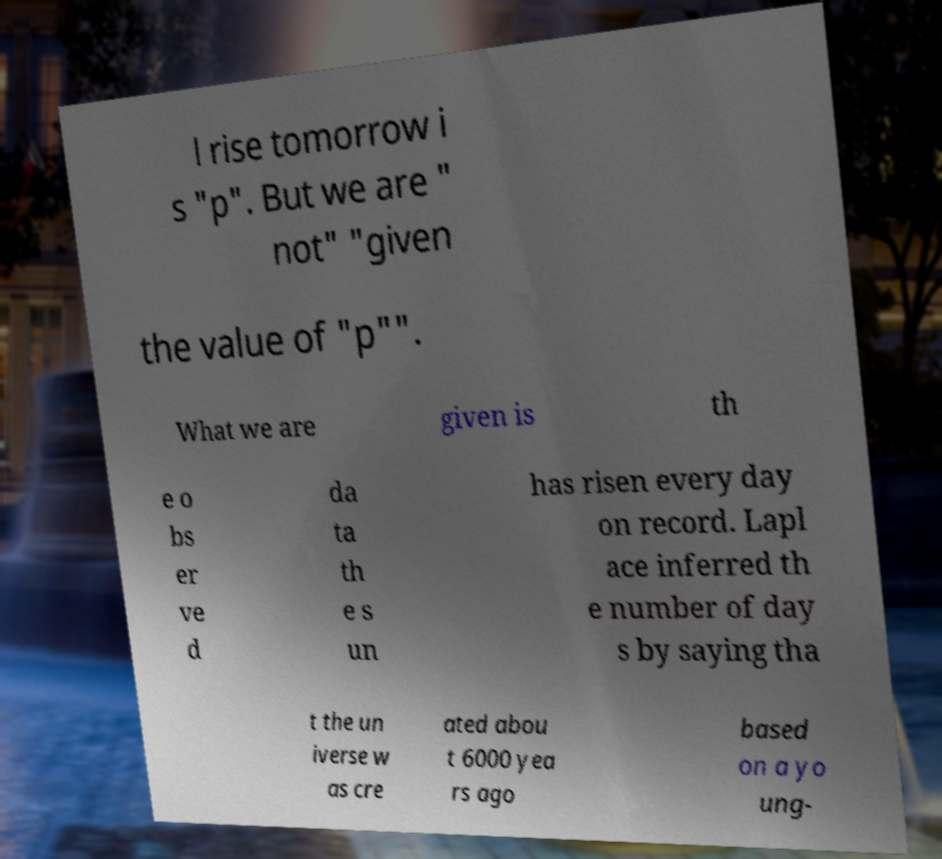There's text embedded in this image that I need extracted. Can you transcribe it verbatim? l rise tomorrow i s "p". But we are " not" "given the value of "p"". What we are given is th e o bs er ve d da ta th e s un has risen every day on record. Lapl ace inferred th e number of day s by saying tha t the un iverse w as cre ated abou t 6000 yea rs ago based on a yo ung- 